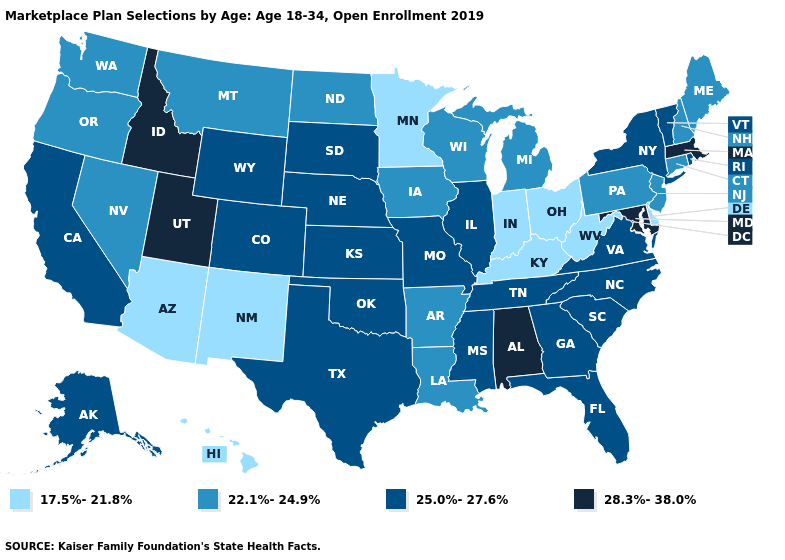Which states hav the highest value in the Northeast?
Short answer required. Massachusetts. Which states have the lowest value in the Northeast?
Keep it brief. Connecticut, Maine, New Hampshire, New Jersey, Pennsylvania. Name the states that have a value in the range 22.1%-24.9%?
Short answer required. Arkansas, Connecticut, Iowa, Louisiana, Maine, Michigan, Montana, Nevada, New Hampshire, New Jersey, North Dakota, Oregon, Pennsylvania, Washington, Wisconsin. What is the value of Wisconsin?
Concise answer only. 22.1%-24.9%. What is the lowest value in the USA?
Quick response, please. 17.5%-21.8%. What is the highest value in the USA?
Concise answer only. 28.3%-38.0%. Among the states that border Rhode Island , which have the highest value?
Concise answer only. Massachusetts. Among the states that border Minnesota , which have the lowest value?
Short answer required. Iowa, North Dakota, Wisconsin. What is the lowest value in the USA?
Answer briefly. 17.5%-21.8%. Does the map have missing data?
Quick response, please. No. What is the value of Nevada?
Quick response, please. 22.1%-24.9%. Name the states that have a value in the range 22.1%-24.9%?
Write a very short answer. Arkansas, Connecticut, Iowa, Louisiana, Maine, Michigan, Montana, Nevada, New Hampshire, New Jersey, North Dakota, Oregon, Pennsylvania, Washington, Wisconsin. What is the value of Maine?
Answer briefly. 22.1%-24.9%. Which states have the lowest value in the USA?
Keep it brief. Arizona, Delaware, Hawaii, Indiana, Kentucky, Minnesota, New Mexico, Ohio, West Virginia. Name the states that have a value in the range 17.5%-21.8%?
Short answer required. Arizona, Delaware, Hawaii, Indiana, Kentucky, Minnesota, New Mexico, Ohio, West Virginia. 